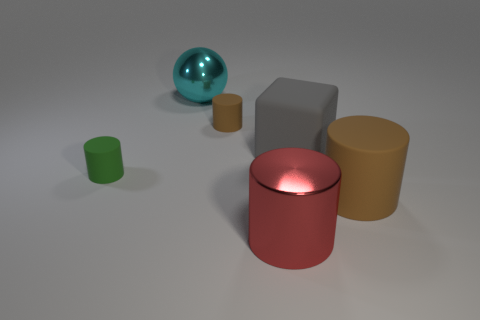What number of other things are the same shape as the large cyan object?
Give a very brief answer. 0. There is a large cylinder that is to the left of the brown cylinder that is in front of the big gray thing; what is it made of?
Provide a short and direct response. Metal. Is there any other thing that is the same size as the block?
Your answer should be compact. Yes. Is the material of the tiny green cylinder the same as the brown cylinder in front of the rubber block?
Offer a terse response. Yes. What material is the thing that is both behind the green matte object and left of the small brown object?
Make the answer very short. Metal. The rubber cylinder that is in front of the small matte object that is in front of the big gray thing is what color?
Give a very brief answer. Brown. What is the material of the brown object behind the green object?
Give a very brief answer. Rubber. Is the number of tiny blue things less than the number of matte cubes?
Provide a short and direct response. Yes. Do the small brown object and the object in front of the big brown object have the same shape?
Give a very brief answer. Yes. The large object that is both in front of the green matte thing and on the left side of the big brown rubber cylinder has what shape?
Provide a succinct answer. Cylinder. 